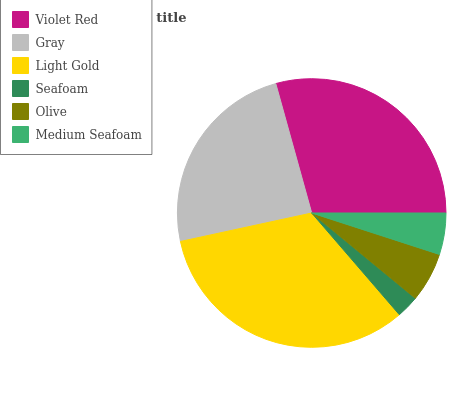Is Seafoam the minimum?
Answer yes or no. Yes. Is Light Gold the maximum?
Answer yes or no. Yes. Is Gray the minimum?
Answer yes or no. No. Is Gray the maximum?
Answer yes or no. No. Is Violet Red greater than Gray?
Answer yes or no. Yes. Is Gray less than Violet Red?
Answer yes or no. Yes. Is Gray greater than Violet Red?
Answer yes or no. No. Is Violet Red less than Gray?
Answer yes or no. No. Is Gray the high median?
Answer yes or no. Yes. Is Olive the low median?
Answer yes or no. Yes. Is Light Gold the high median?
Answer yes or no. No. Is Gray the low median?
Answer yes or no. No. 